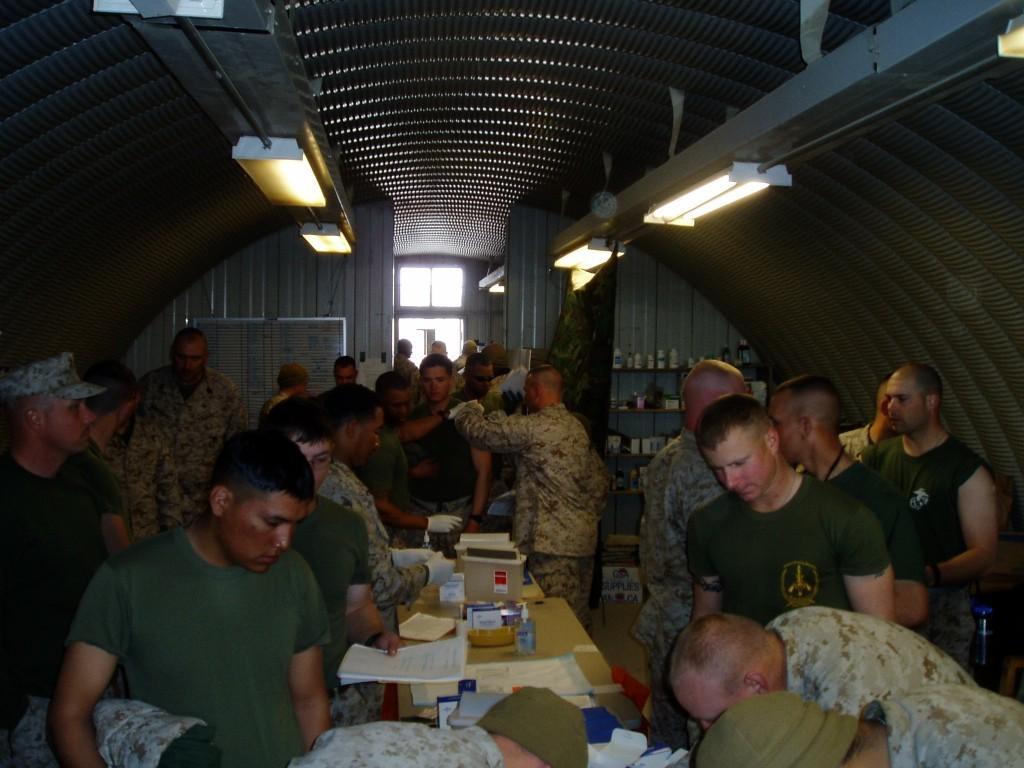In one or two sentences, can you explain what this image depicts? In this picture we can see some people are standing, there is a table in the middle, we can see some papers, a box and other things present on the table, in the background there are some shelves, there are some things present on these shelves, we can see lights at the top of the picture. 